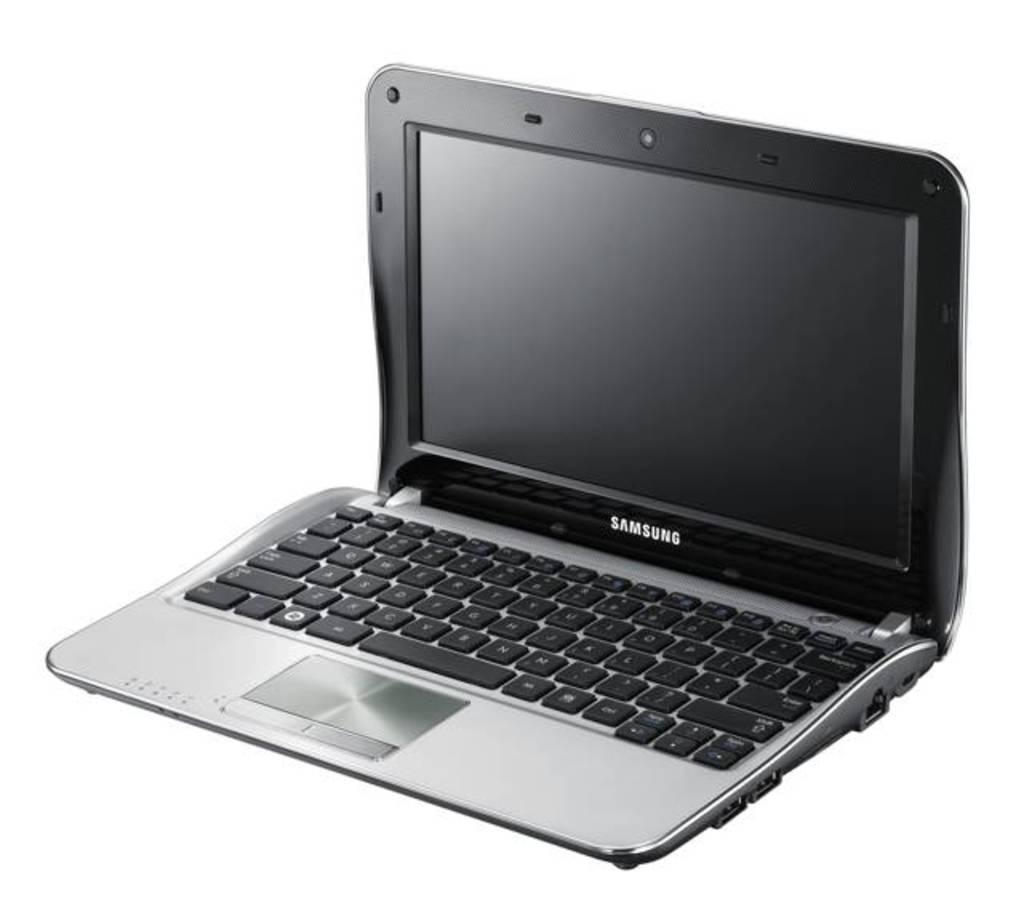<image>
Render a clear and concise summary of the photo. the word samsung that is on a laptop 